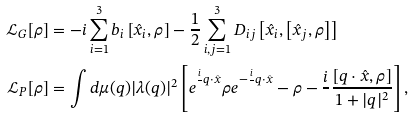<formula> <loc_0><loc_0><loc_500><loc_500>\mathcal { L } _ { G } [ \rho ] & = - i \sum _ { i = 1 } ^ { 3 } { b } _ { i } \left [ \hat { x } _ { i } , \rho \right ] - \frac { 1 } { 2 } \sum _ { i , j = 1 } ^ { 3 } { { D } _ { i j } } \left [ \hat { x } _ { i } , \left [ \hat { x } _ { j } , \rho \right ] \right ] \\ \mathcal { L } _ { P } [ \rho ] & = \int d \mu ( q ) | \lambda ( q ) | ^ { 2 } \left [ e ^ { \frac { i } { } q \cdot \hat { x } } \rho e ^ { - \frac { i } { } q \cdot \hat { x } } - \rho - \frac { i } { } \frac { [ q \cdot \hat { x } , \rho ] } { 1 + | q | ^ { 2 } } \right ] ,</formula> 